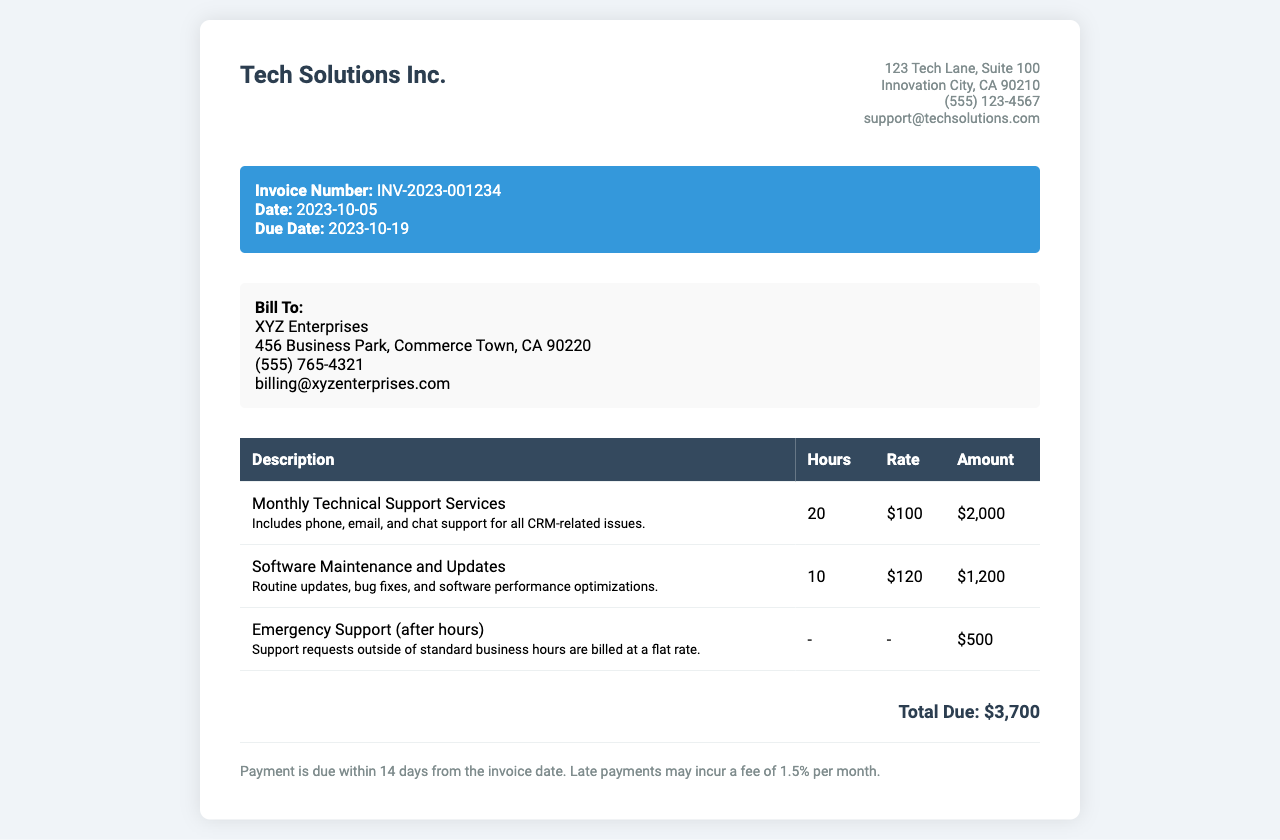What is the invoice number? The invoice number is listed in the invoice details section, identified as INV-2023-001234.
Answer: INV-2023-001234 When is the due date? The due date is specified in the invoice details section, which states the due date as 2023-10-19.
Answer: 2023-10-19 How many hours were billed for Monthly Technical Support Services? The hours billed for Monthly Technical Support Services are indicated in the table corresponding to that service, which shows 20 hours.
Answer: 20 What is the total due amount? The total due amount is summarized at the bottom of the invoice, which clearly states the total as $3,700.
Answer: $3,700 What does the emergency support refer to? Emergency support is defined in the table as support requests outside of standard business hours which are billed at a flat rate.
Answer: Support requests outside standard business hours How many hours were dedicated to Software Maintenance and Updates? The document specifies in the service table that 10 hours were dedicated to Software Maintenance and Updates.
Answer: 10 What is the hourly rate for Software Maintenance and Updates? The hourly rate for Software Maintenance and Updates is stated in the service table as $120.
Answer: $120 What is the payment term specified in the invoice? The payment term is described in the payment terms section, indicating that payment is due within 14 days from the invoice date.
Answer: 14 days 